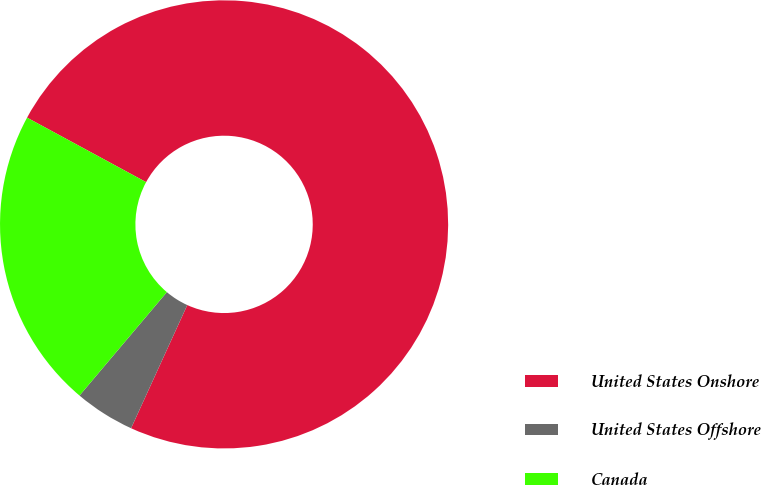<chart> <loc_0><loc_0><loc_500><loc_500><pie_chart><fcel>United States Onshore<fcel>United States Offshore<fcel>Canada<nl><fcel>73.91%<fcel>4.35%<fcel>21.74%<nl></chart> 